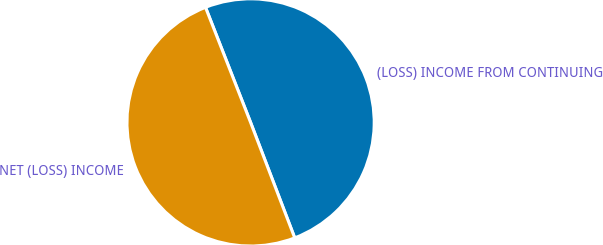<chart> <loc_0><loc_0><loc_500><loc_500><pie_chart><fcel>(LOSS) INCOME FROM CONTINUING<fcel>NET (LOSS) INCOME<nl><fcel>50.13%<fcel>49.87%<nl></chart> 